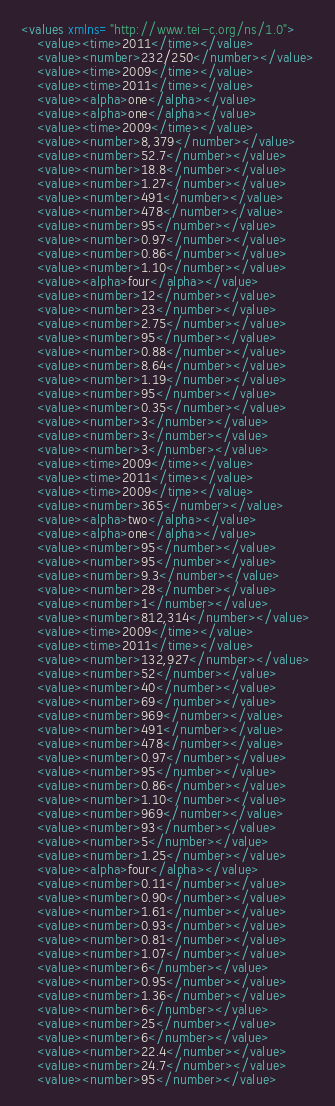<code> <loc_0><loc_0><loc_500><loc_500><_XML_><values xmlns="http://www.tei-c.org/ns/1.0">
    <value><time>2011</time></value>
	<value><number>232/250</number></value>
	<value><time>2009</time></value>
	<value><time>2011</time></value>
	<value><alpha>one</alpha></value>
	<value><alpha>one</alpha></value>
	<value><time>2009</time></value>
	<value><number>8,379</number></value>
	<value><number>52.7</number></value>
	<value><number>18.8</number></value>
	<value><number>1.27</number></value>
	<value><number>491</number></value>
	<value><number>478</number></value>
	<value><number>95</number></value>
	<value><number>0.97</number></value>
	<value><number>0.86</number></value>
	<value><number>1.10</number></value>
	<value><alpha>four</alpha></value>
	<value><number>12</number></value>
	<value><number>23</number></value>
	<value><number>2.75</number></value>
	<value><number>95</number></value>
	<value><number>0.88</number></value>
	<value><number>8.64</number></value>
	<value><number>1.19</number></value>
	<value><number>95</number></value>
	<value><number>0.35</number></value>
	<value><number>3</number></value>
	<value><number>3</number></value>
	<value><number>3</number></value>
	<value><time>2009</time></value>
	<value><time>2011</time></value>
	<value><time>2009</time></value>
	<value><number>365</number></value>
	<value><alpha>two</alpha></value>
	<value><alpha>one</alpha></value>
	<value><number>95</number></value>
	<value><number>95</number></value>
	<value><number>9.3</number></value>
	<value><number>28</number></value>
	<value><number>1</number></value>
	<value><number>812,314</number></value>
	<value><time>2009</time></value>
	<value><time>2011</time></value>
	<value><number>132,927</number></value>
	<value><number>52</number></value>
	<value><number>40</number></value>
	<value><number>69</number></value>
	<value><number>969</number></value>
	<value><number>491</number></value>
	<value><number>478</number></value>
	<value><number>0.97</number></value>
	<value><number>95</number></value>
	<value><number>0.86</number></value>
	<value><number>1.10</number></value>
	<value><number>969</number></value>
	<value><number>93</number></value>
	<value><number>5</number></value>
	<value><number>1.25</number></value>
	<value><alpha>four</alpha></value>
	<value><number>0.11</number></value>
	<value><number>0.90</number></value>
	<value><number>1.61</number></value>
	<value><number>0.93</number></value>
	<value><number>0.81</number></value>
	<value><number>1.07</number></value>
	<value><number>6</number></value>
	<value><number>0.95</number></value>
	<value><number>1.36</number></value>
	<value><number>6</number></value>
	<value><number>25</number></value>
	<value><number>6</number></value>
	<value><number>22.4</number></value>
	<value><number>24.7</number></value>
	<value><number>95</number></value></code> 